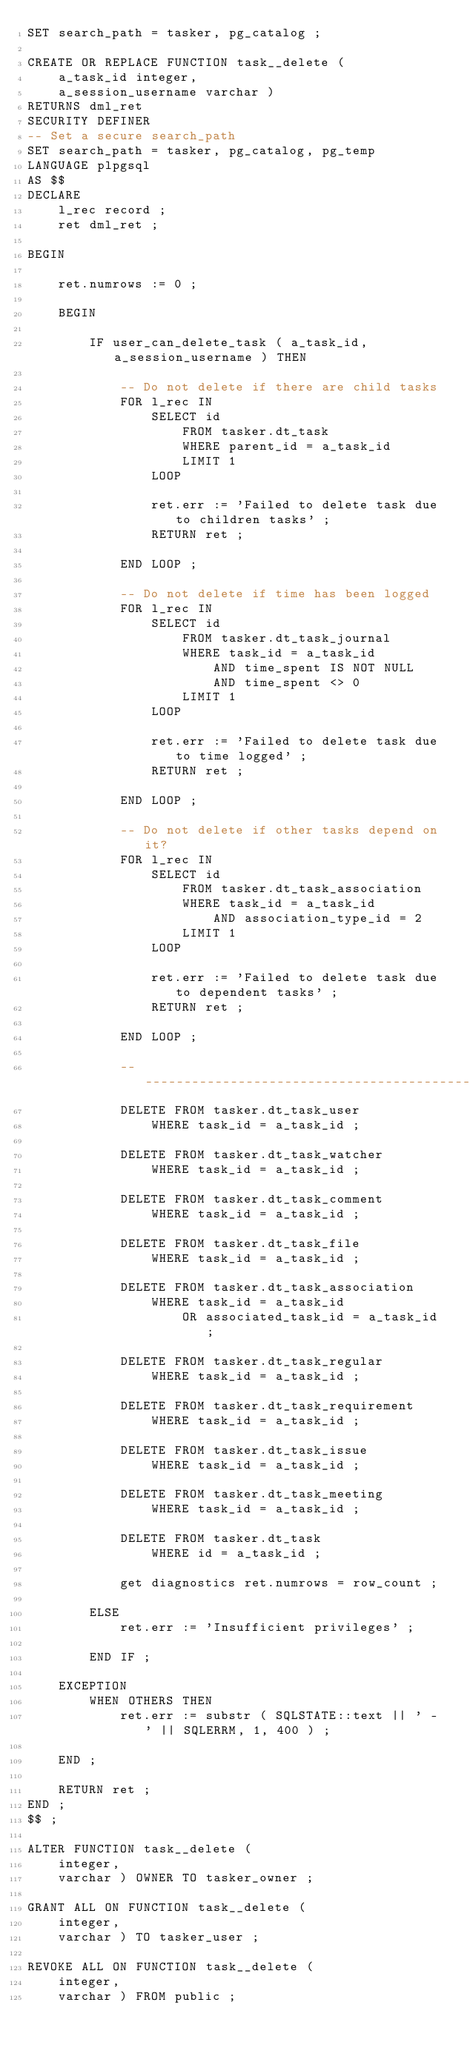<code> <loc_0><loc_0><loc_500><loc_500><_SQL_>SET search_path = tasker, pg_catalog ;

CREATE OR REPLACE FUNCTION task__delete (
    a_task_id integer,
    a_session_username varchar )
RETURNS dml_ret
SECURITY DEFINER
-- Set a secure search_path
SET search_path = tasker, pg_catalog, pg_temp
LANGUAGE plpgsql
AS $$
DECLARE
    l_rec record ;
    ret dml_ret ;

BEGIN

    ret.numrows := 0 ;

    BEGIN

        IF user_can_delete_task ( a_task_id, a_session_username ) THEN

            -- Do not delete if there are child tasks
            FOR l_rec IN
                SELECT id
                    FROM tasker.dt_task
                    WHERE parent_id = a_task_id
                    LIMIT 1
                LOOP

                ret.err := 'Failed to delete task due to children tasks' ;
                RETURN ret ;

            END LOOP ;

            -- Do not delete if time has been logged
            FOR l_rec IN
                SELECT id
                    FROM tasker.dt_task_journal
                    WHERE task_id = a_task_id
                        AND time_spent IS NOT NULL
                        AND time_spent <> 0
                    LIMIT 1
                LOOP

                ret.err := 'Failed to delete task due to time logged' ;
                RETURN ret ;

            END LOOP ;

            -- Do not delete if other tasks depend on it?
            FOR l_rec IN
                SELECT id
                    FROM tasker.dt_task_association
                    WHERE task_id = a_task_id
                        AND association_type_id = 2
                    LIMIT 1
                LOOP

                ret.err := 'Failed to delete task due to dependent tasks' ;
                RETURN ret ;

            END LOOP ;

            ----------------------------------------------------------------
            DELETE FROM tasker.dt_task_user
                WHERE task_id = a_task_id ;

            DELETE FROM tasker.dt_task_watcher
                WHERE task_id = a_task_id ;

            DELETE FROM tasker.dt_task_comment
                WHERE task_id = a_task_id ;

            DELETE FROM tasker.dt_task_file
                WHERE task_id = a_task_id ;

            DELETE FROM tasker.dt_task_association
                WHERE task_id = a_task_id
                    OR associated_task_id = a_task_id ;

            DELETE FROM tasker.dt_task_regular
                WHERE task_id = a_task_id ;

            DELETE FROM tasker.dt_task_requirement
                WHERE task_id = a_task_id ;

            DELETE FROM tasker.dt_task_issue
                WHERE task_id = a_task_id ;

            DELETE FROM tasker.dt_task_meeting
                WHERE task_id = a_task_id ;

            DELETE FROM tasker.dt_task
                WHERE id = a_task_id ;

            get diagnostics ret.numrows = row_count ;

        ELSE
            ret.err := 'Insufficient privileges' ;

        END IF ;

    EXCEPTION
        WHEN OTHERS THEN
            ret.err := substr ( SQLSTATE::text || ' - ' || SQLERRM, 1, 400 ) ;

    END ;

    RETURN ret ;
END ;
$$ ;

ALTER FUNCTION task__delete (
    integer,
    varchar ) OWNER TO tasker_owner ;

GRANT ALL ON FUNCTION task__delete (
    integer,
    varchar ) TO tasker_user ;

REVOKE ALL ON FUNCTION task__delete (
    integer,
    varchar ) FROM public ;
</code> 